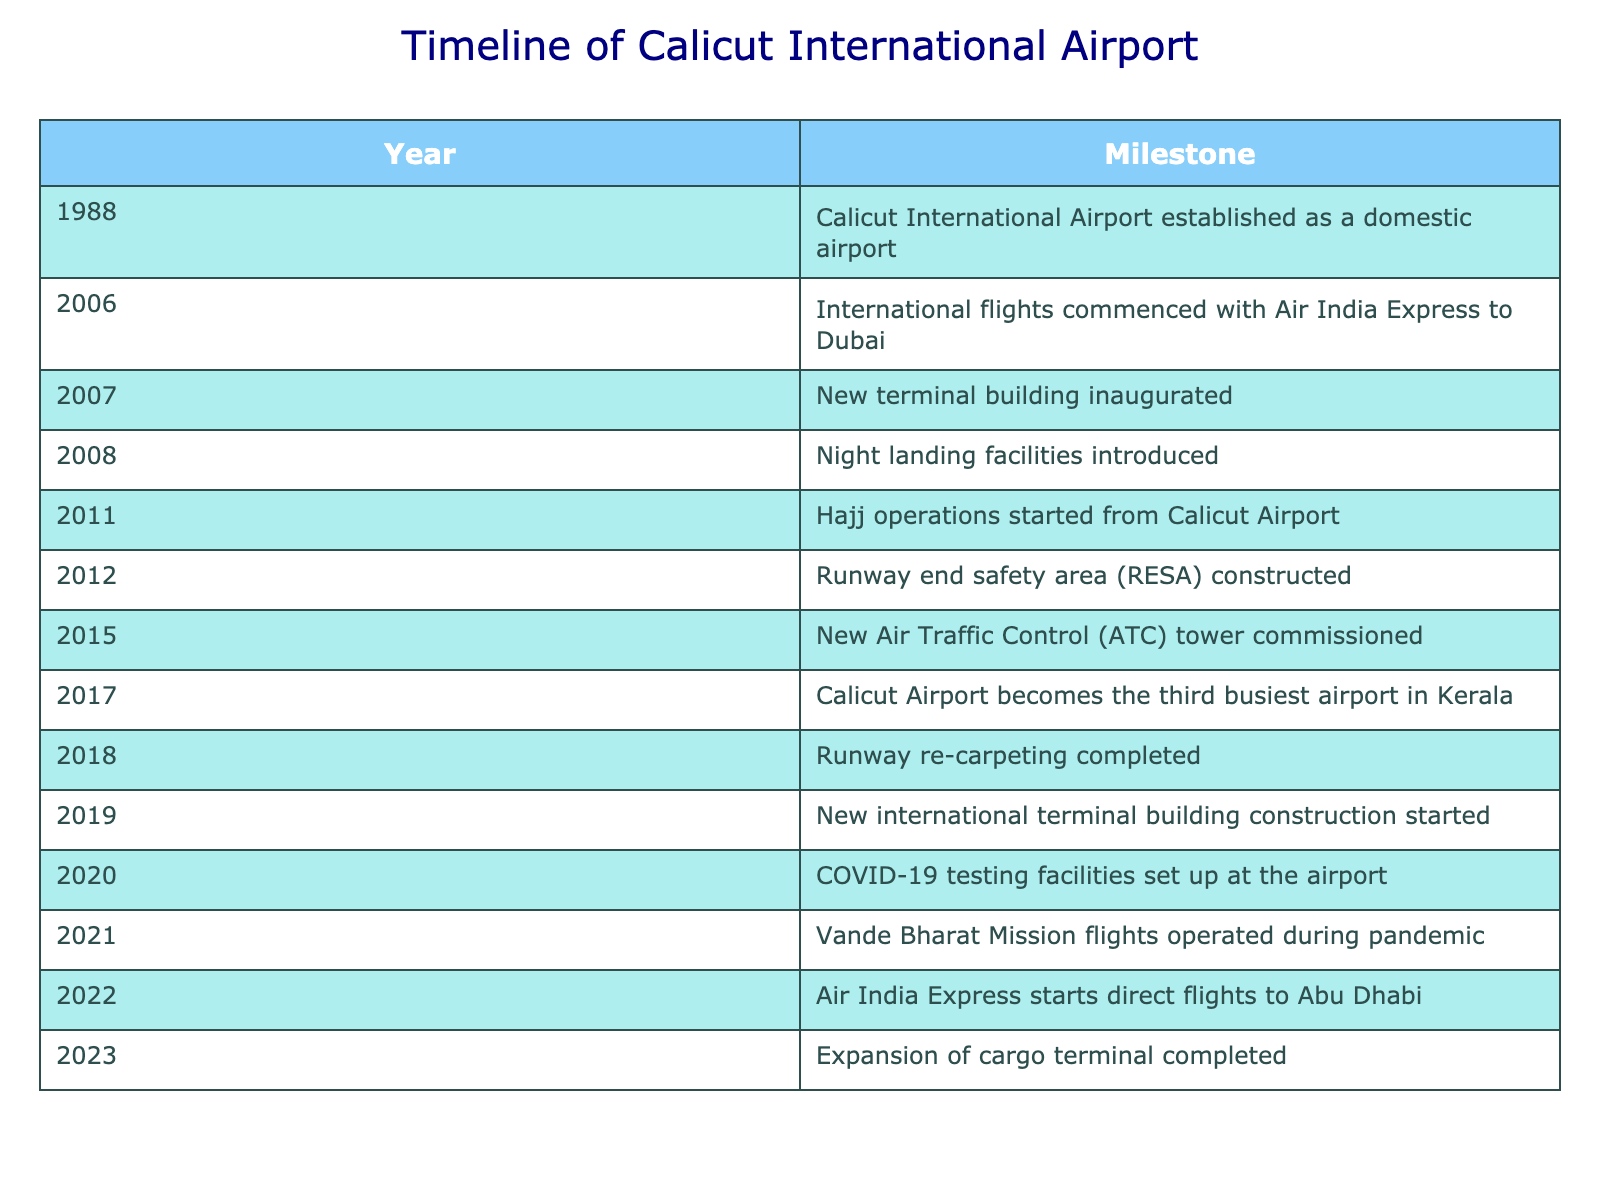What year was Calicut International Airport established? The table clearly states that Calicut International Airport was established in the year 1988.
Answer: 1988 Which event occurred in 2019? According to the table, the event that occurred in 2019 was the construction of a new international terminal building starting.
Answer: New international terminal building construction started Was there an event related to Hajj operations at Calicut Airport? Yes, the table indicates that Hajj operations started from Calicut Airport in the year 2011.
Answer: Yes How many years after its establishment did international flights commence? Calicut International Airport was established in 1988, and international flights commenced in 2006. The difference is 2006 - 1988 = 18 years.
Answer: 18 years In which year did the runway re-carpeting get completed? The table shows that the runway re-carpeting was completed in 2018.
Answer: 2018 Has Calicut Airport ever been the third busiest airport in Kerala? Yes, the table confirms that Calicut Airport became the third busiest airport in Kerala in the year 2017.
Answer: Yes What was the last event listed in the table? The last event in the table is the completion of the expansion of the cargo terminal, which took place in 2023.
Answer: Expansion of cargo terminal completed How many significant events occurred between 2010 and 2020? The events between 2010 and 2020 are: Hajj operations started in 2011, RESA constructed in 2012, ATC tower commissioned in 2015, a new terminal construction started in 2019, and COVID-19 testing facilities set up in 2020. That totals to 5 significant events.
Answer: 5 events Which years saw the introduction of new facilities at Calicut Airport? The years with the introduction of new facilities include: 2008 (night landing facilities), 2012 (RESA constructed), 2015 (ATC tower commissioned), and 2020 (COVID-19 testing facilities). This totals to 4 years.
Answer: 4 years 